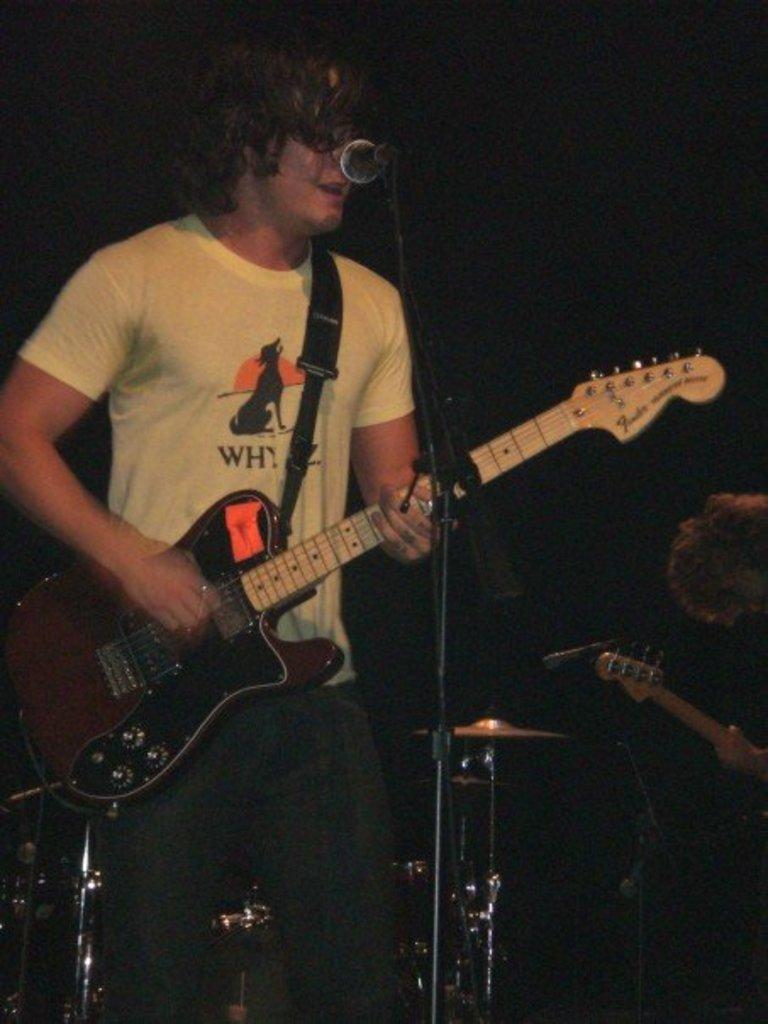What is the man in the image doing? The man is playing a guitar in the image. What object is present that is commonly used for amplifying sound? There is a microphone in the image. What type of pest can be seen crawling on the base of the microphone in the image? There is no pest visible on the microphone or anywhere else in the image. 